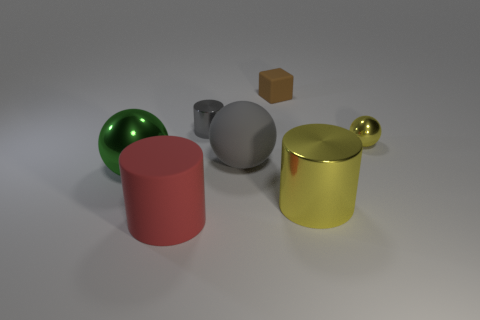Add 3 green metallic spheres. How many objects exist? 10 Subtract all large yellow cylinders. How many cylinders are left? 2 Subtract all cubes. How many objects are left? 6 Subtract all cyan balls. Subtract all cyan cylinders. How many balls are left? 3 Subtract 1 yellow cylinders. How many objects are left? 6 Subtract all large blue metallic cylinders. Subtract all tiny yellow spheres. How many objects are left? 6 Add 6 yellow shiny cylinders. How many yellow shiny cylinders are left? 7 Add 5 yellow cylinders. How many yellow cylinders exist? 6 